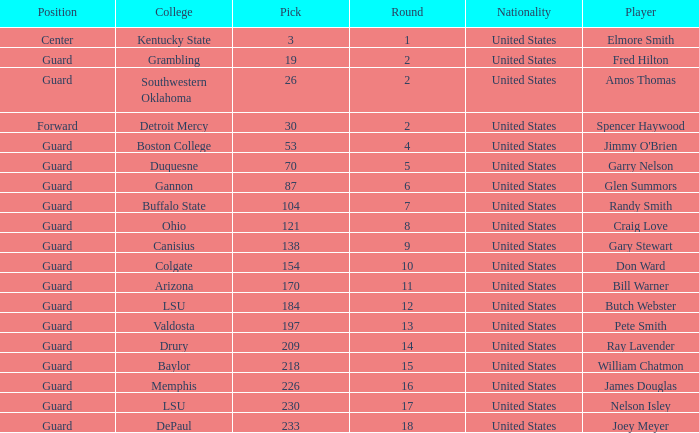WHAT IS THE NATIONALITY FOR SOUTHWESTERN OKLAHOMA? United States. 